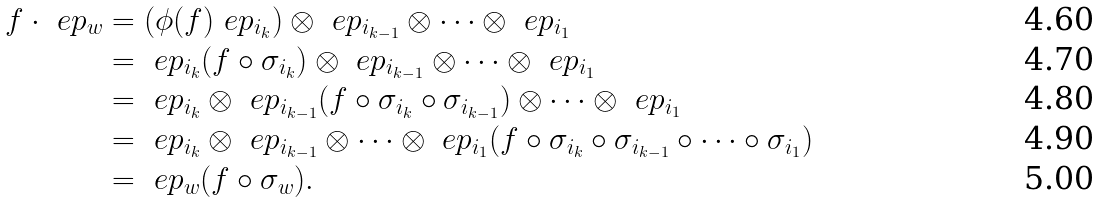Convert formula to latex. <formula><loc_0><loc_0><loc_500><loc_500>f \cdot \ e p _ { w } & = ( \phi ( f ) \ e p _ { i _ { k } } ) \otimes \ e p _ { i _ { k - 1 } } \otimes \dots \otimes \ e p _ { i _ { 1 } } \\ & = \ e p _ { i _ { k } } ( f \circ \sigma _ { i _ { k } } ) \otimes \ e p _ { i _ { k - 1 } } \otimes \dots \otimes \ e p _ { i _ { 1 } } \\ & = \ e p _ { i _ { k } } \otimes \ e p _ { i _ { k - 1 } } ( f \circ \sigma _ { i _ { k } } \circ \sigma _ { i _ { k - 1 } } ) \otimes \dots \otimes \ e p _ { i _ { 1 } } \\ & = \ e p _ { i _ { k } } \otimes \ e p _ { i _ { k - 1 } } \otimes \dots \otimes \ e p _ { i _ { 1 } } ( f \circ \sigma _ { i _ { k } } \circ \sigma _ { i _ { k - 1 } } \circ \cdots \circ \sigma _ { i _ { 1 } } ) \\ & = \ e p _ { w } ( f \circ \sigma _ { w } ) .</formula> 